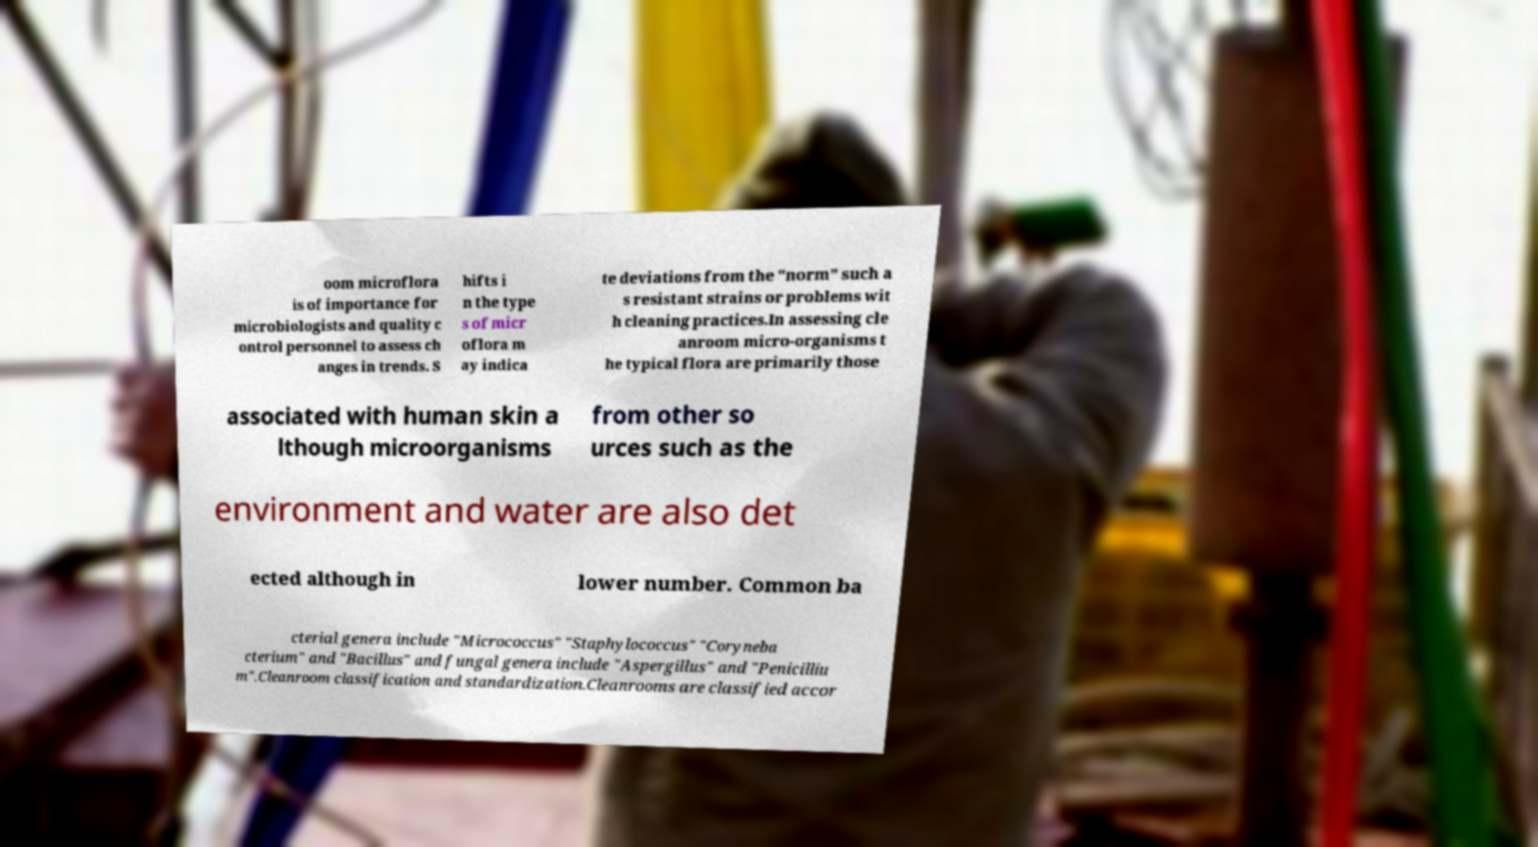I need the written content from this picture converted into text. Can you do that? oom microflora is of importance for microbiologists and quality c ontrol personnel to assess ch anges in trends. S hifts i n the type s of micr oflora m ay indica te deviations from the "norm" such a s resistant strains or problems wit h cleaning practices.In assessing cle anroom micro-organisms t he typical flora are primarily those associated with human skin a lthough microorganisms from other so urces such as the environment and water are also det ected although in lower number. Common ba cterial genera include "Micrococcus" "Staphylococcus" "Coryneba cterium" and "Bacillus" and fungal genera include "Aspergillus" and "Penicilliu m".Cleanroom classification and standardization.Cleanrooms are classified accor 